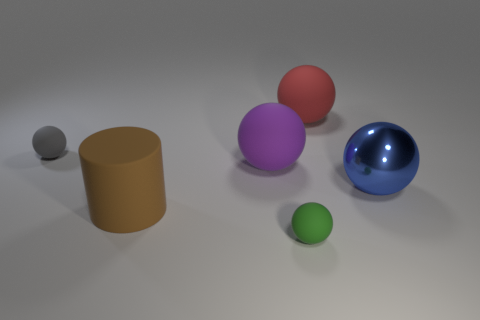Are there the same number of matte things that are to the left of the red sphere and big things?
Provide a short and direct response. Yes. Are there any other things that have the same material as the blue thing?
Make the answer very short. No. How many tiny objects are either cyan metal cylinders or green rubber balls?
Your answer should be very brief. 1. Is the material of the big ball that is right of the large red thing the same as the brown object?
Ensure brevity in your answer.  No. There is a big sphere that is in front of the large ball to the left of the red matte ball; what is its material?
Your answer should be very brief. Metal. What number of blue metallic things have the same shape as the red object?
Offer a terse response. 1. There is a green sphere that is in front of the small sphere that is behind the thing to the right of the big red object; what size is it?
Ensure brevity in your answer.  Small. How many blue things are either matte things or tiny rubber balls?
Keep it short and to the point. 0. Is the shape of the small thing that is to the left of the rubber cylinder the same as  the red matte thing?
Make the answer very short. Yes. Are there more purple rubber spheres to the left of the red rubber thing than big purple cylinders?
Provide a short and direct response. Yes. 